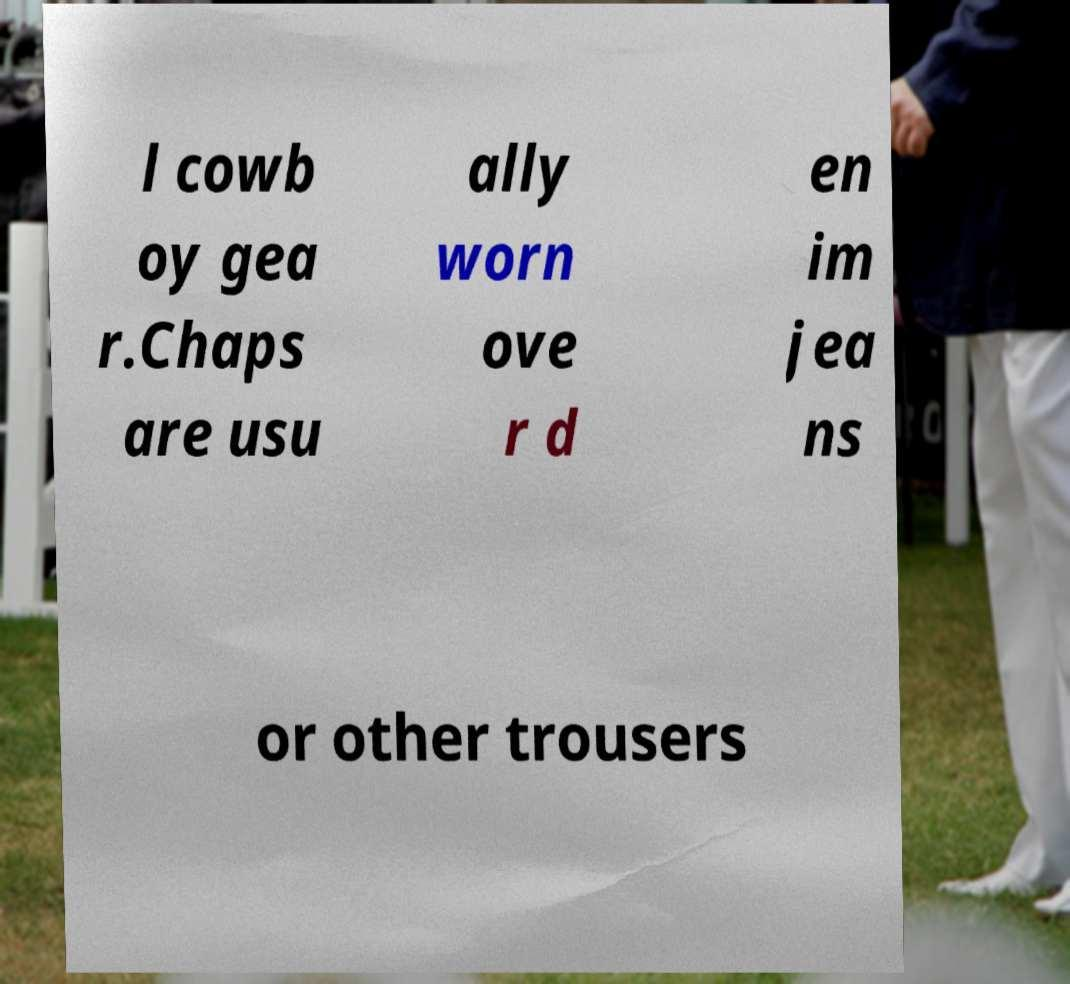Please read and relay the text visible in this image. What does it say? l cowb oy gea r.Chaps are usu ally worn ove r d en im jea ns or other trousers 